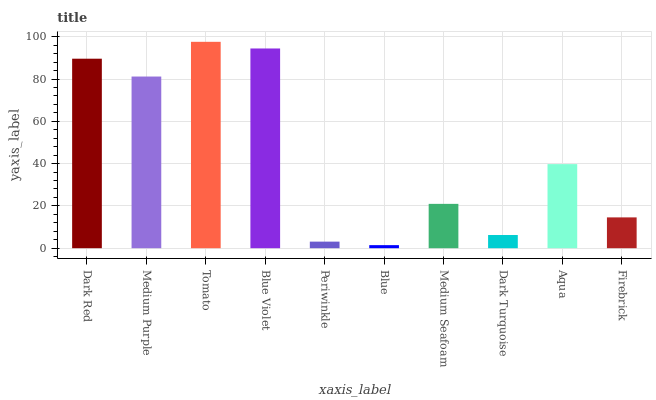Is Blue the minimum?
Answer yes or no. Yes. Is Tomato the maximum?
Answer yes or no. Yes. Is Medium Purple the minimum?
Answer yes or no. No. Is Medium Purple the maximum?
Answer yes or no. No. Is Dark Red greater than Medium Purple?
Answer yes or no. Yes. Is Medium Purple less than Dark Red?
Answer yes or no. Yes. Is Medium Purple greater than Dark Red?
Answer yes or no. No. Is Dark Red less than Medium Purple?
Answer yes or no. No. Is Aqua the high median?
Answer yes or no. Yes. Is Medium Seafoam the low median?
Answer yes or no. Yes. Is Medium Purple the high median?
Answer yes or no. No. Is Dark Turquoise the low median?
Answer yes or no. No. 